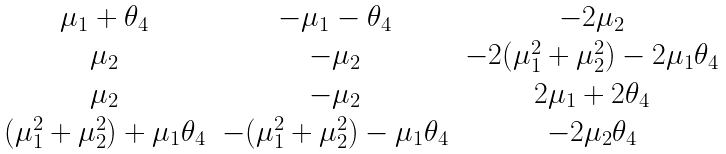Convert formula to latex. <formula><loc_0><loc_0><loc_500><loc_500>\begin{matrix} \mu _ { 1 } + \theta _ { 4 } & - \mu _ { 1 } - \theta _ { 4 } & - 2 \mu _ { 2 } \\ \mu _ { 2 } & - \mu _ { 2 } & - 2 ( \mu _ { 1 } ^ { 2 } + \mu _ { 2 } ^ { 2 } ) - 2 \mu _ { 1 } \theta _ { 4 } \\ \mu _ { 2 } & - \mu _ { 2 } & 2 \mu _ { 1 } + 2 \theta _ { 4 } \\ ( \mu _ { 1 } ^ { 2 } + \mu _ { 2 } ^ { 2 } ) + \mu _ { 1 } \theta _ { 4 } & - ( \mu _ { 1 } ^ { 2 } + \mu _ { 2 } ^ { 2 } ) - \mu _ { 1 } \theta _ { 4 } & - 2 \mu _ { 2 } \theta _ { 4 } \end{matrix}</formula> 